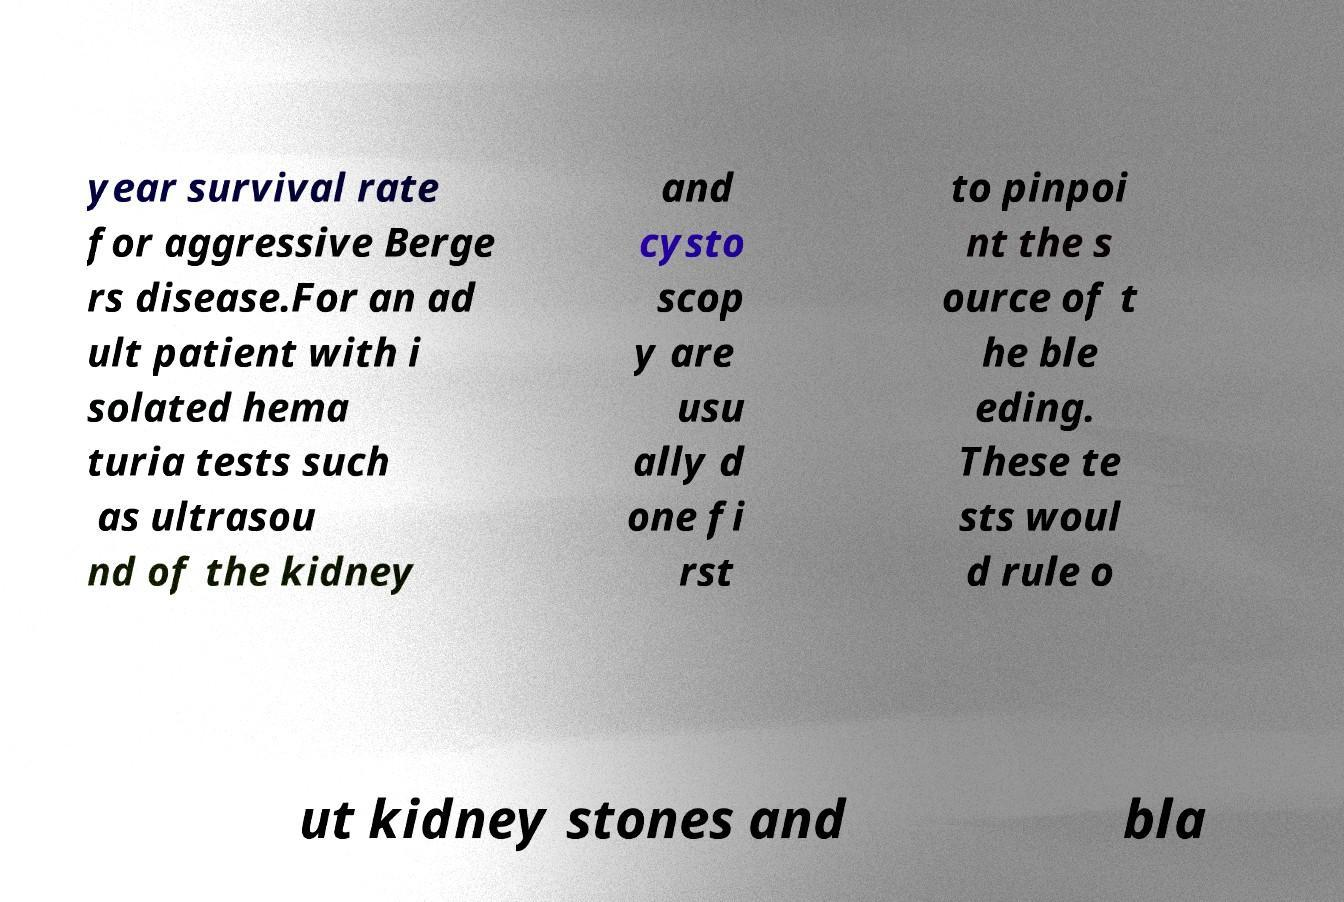I need the written content from this picture converted into text. Can you do that? year survival rate for aggressive Berge rs disease.For an ad ult patient with i solated hema turia tests such as ultrasou nd of the kidney and cysto scop y are usu ally d one fi rst to pinpoi nt the s ource of t he ble eding. These te sts woul d rule o ut kidney stones and bla 